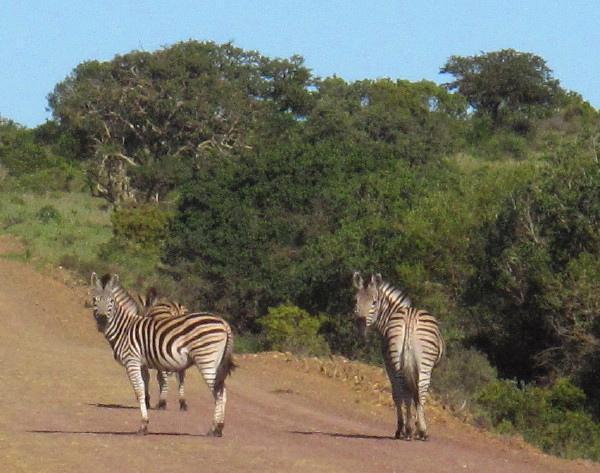How many horses are there?
Give a very brief answer. 0. How many zebras are there?
Give a very brief answer. 2. How many cats are in this photograph?
Give a very brief answer. 0. 